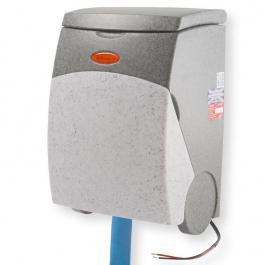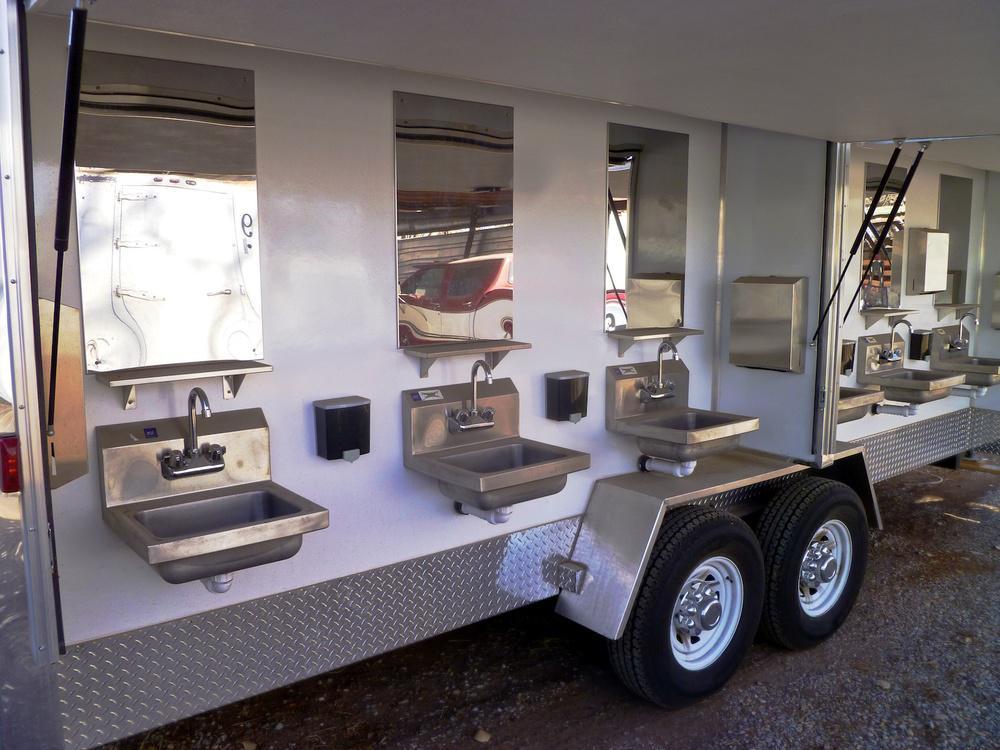The first image is the image on the left, the second image is the image on the right. Assess this claim about the two images: "There are exactly three visible containers of soap, two in one image and one in the other.". Correct or not? Answer yes or no. No. The first image is the image on the left, the second image is the image on the right. Considering the images on both sides, is "There are more than two dispensers." valid? Answer yes or no. Yes. 